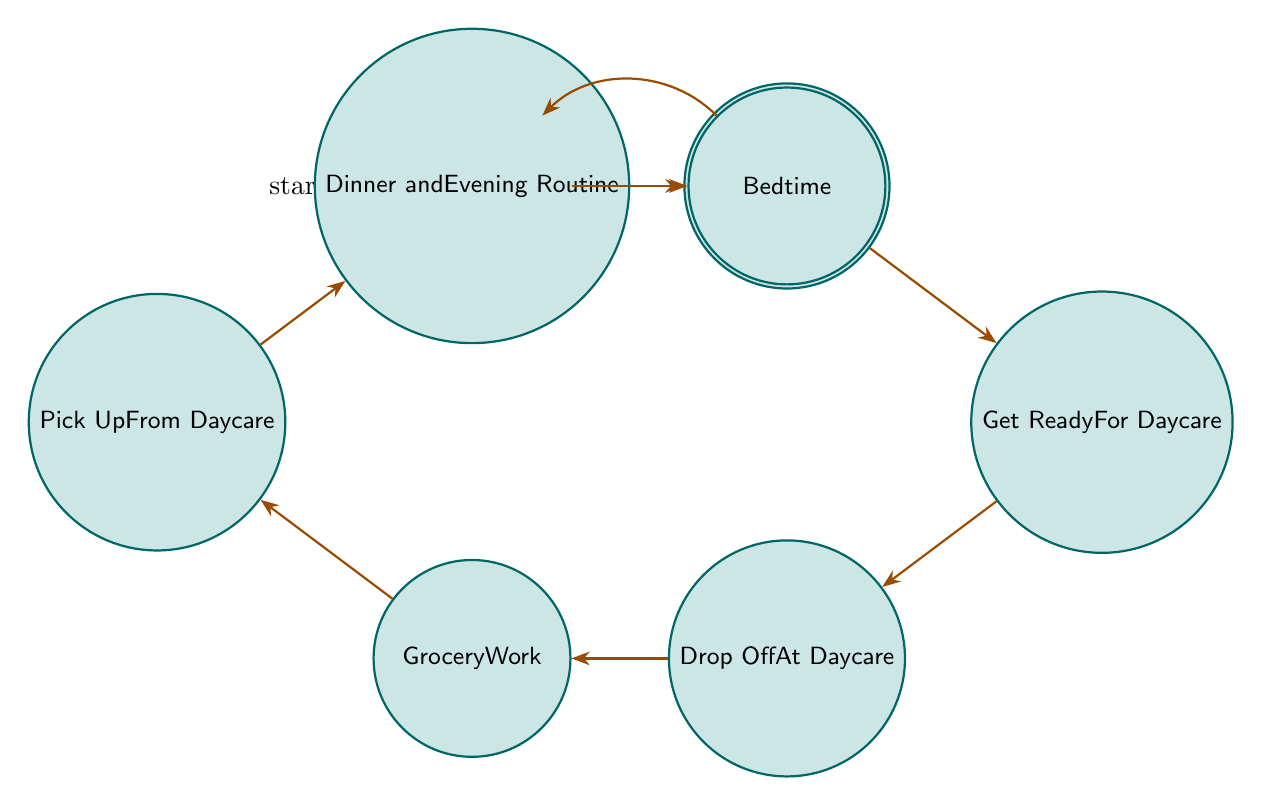What is the first state in the diagram? The first state is indicated as the initial state in the diagram. From the visualization, "WakeUp" is the first node where the flow begins.
Answer: WakeUp How many states are present in the diagram? To find the total number of states, count each unique state mentioned in the diagram. There are 8 states: WakeUp, PrepareBreakfast, GetReadyForDaycare, DropOffAtDaycare, GroceryWork, PickUpFromDaycare, DinnerAndEveningRoutine, and Bedtime.
Answer: 8 Which state comes after "DropOffAtDaycare"? The transitions in the diagram show the flow from one state to another. Specifically, after "DropOffAtDaycare," the next state is "GroceryWork."
Answer: GroceryWork What is the relationship between "GroceryWork" and "PickUpFromDaycare"? The relationship can be identified by examining the arrows. The diagram shows a directed edge leading from "GroceryWork" to "PickUpFromDaycare," indicating that the state transitions in this order.
Answer: GroceryWork → PickUpFromDaycare How many transitions are present in the diagram? Each connection between the states represents a transition. Counting these arrows in the diagram leads to 7 transitions.
Answer: 7 What is the last state that precedes "Bedtime"? By reviewing the flow of the diagram, it’s evident that the state directly before "Bedtime" is "DinnerAndEveningRoutine," which comes before it in the sequence of transitions.
Answer: DinnerAndEveningRoutine Which state leads back to "WakeUp"? The diagram indicates a transition that connects from "Bedtime" back to "WakeUp." This is specifically shown as a return path in the flow of the states.
Answer: Bedtime If you are in the state "PickUpFromDaycare," what is the next state? According to the transitions defined in the diagram, the state that follows "PickUpFromDaycare" is "DinnerAndEveningRoutine."
Answer: DinnerAndEveningRoutine 